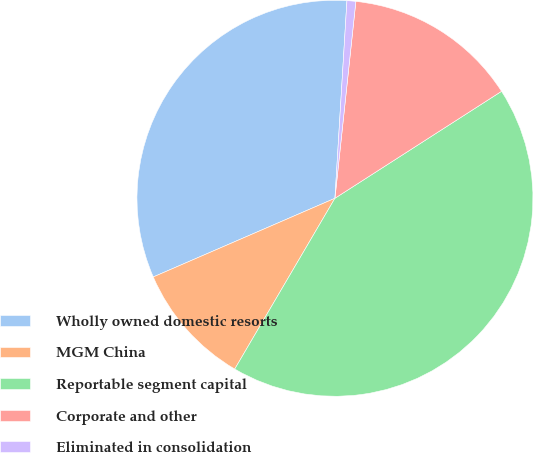<chart> <loc_0><loc_0><loc_500><loc_500><pie_chart><fcel>Wholly owned domestic resorts<fcel>MGM China<fcel>Reportable segment capital<fcel>Corporate and other<fcel>Eliminated in consolidation<nl><fcel>32.47%<fcel>10.05%<fcel>42.53%<fcel>14.23%<fcel>0.72%<nl></chart> 